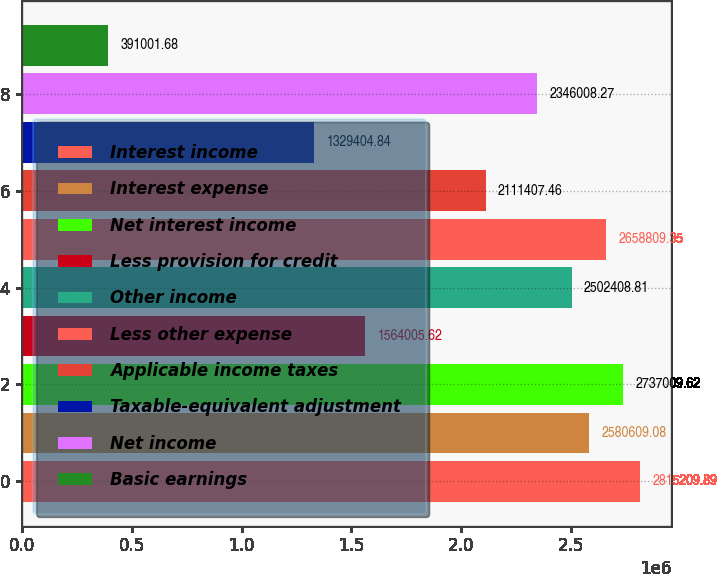Convert chart. <chart><loc_0><loc_0><loc_500><loc_500><bar_chart><fcel>Interest income<fcel>Interest expense<fcel>Net interest income<fcel>Less provision for credit<fcel>Other income<fcel>Less other expense<fcel>Applicable income taxes<fcel>Taxable-equivalent adjustment<fcel>Net income<fcel>Basic earnings<nl><fcel>2.81521e+06<fcel>2.58061e+06<fcel>2.73701e+06<fcel>1.56401e+06<fcel>2.50241e+06<fcel>2.65881e+06<fcel>2.11141e+06<fcel>1.3294e+06<fcel>2.34601e+06<fcel>391002<nl></chart> 